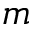Convert formula to latex. <formula><loc_0><loc_0><loc_500><loc_500>m</formula> 